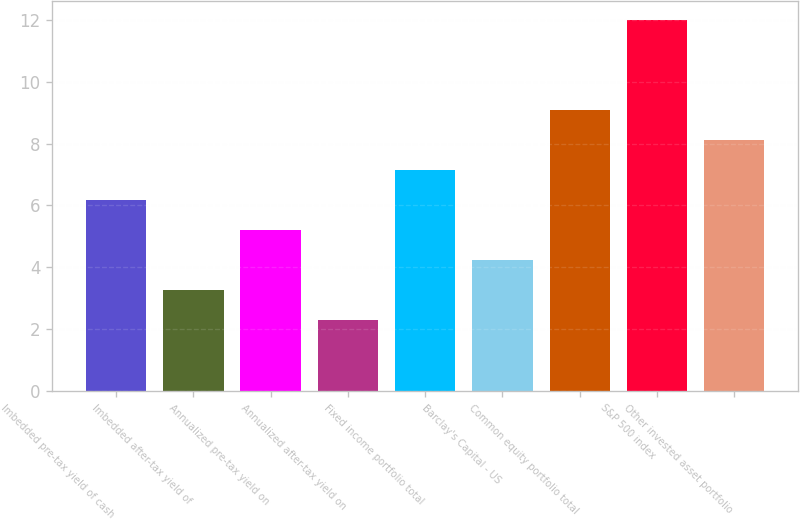<chart> <loc_0><loc_0><loc_500><loc_500><bar_chart><fcel>Imbedded pre-tax yield of cash<fcel>Imbedded after-tax yield of<fcel>Annualized pre-tax yield on<fcel>Annualized after-tax yield on<fcel>Fixed income portfolio total<fcel>Barclay's Capital - US<fcel>Common equity portfolio total<fcel>S&P 500 index<fcel>Other invested asset portfolio<nl><fcel>6.18<fcel>3.27<fcel>5.21<fcel>2.3<fcel>7.15<fcel>4.24<fcel>9.09<fcel>12<fcel>8.12<nl></chart> 